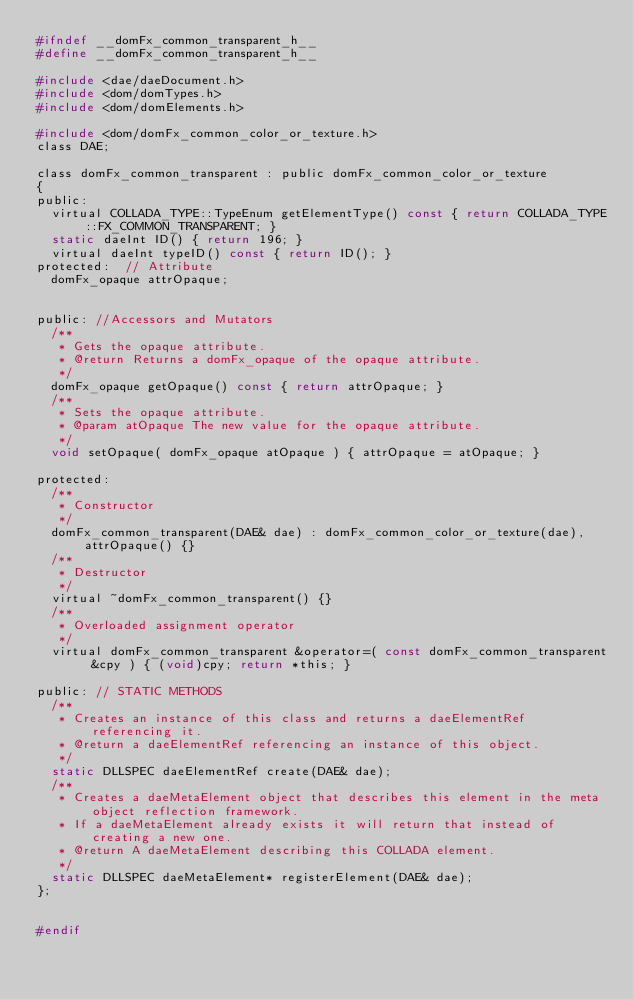Convert code to text. <code><loc_0><loc_0><loc_500><loc_500><_C_>#ifndef __domFx_common_transparent_h__
#define __domFx_common_transparent_h__

#include <dae/daeDocument.h>
#include <dom/domTypes.h>
#include <dom/domElements.h>

#include <dom/domFx_common_color_or_texture.h>
class DAE;

class domFx_common_transparent : public domFx_common_color_or_texture
{
public:
	virtual COLLADA_TYPE::TypeEnum getElementType() const { return COLLADA_TYPE::FX_COMMON_TRANSPARENT; }
	static daeInt ID() { return 196; }
	virtual daeInt typeID() const { return ID(); }
protected:  // Attribute
	domFx_opaque attrOpaque;


public:	//Accessors and Mutators
	/**
	 * Gets the opaque attribute.
	 * @return Returns a domFx_opaque of the opaque attribute.
	 */
	domFx_opaque getOpaque() const { return attrOpaque; }
	/**
	 * Sets the opaque attribute.
	 * @param atOpaque The new value for the opaque attribute.
	 */
	void setOpaque( domFx_opaque atOpaque ) { attrOpaque = atOpaque; }

protected:
	/**
	 * Constructor
	 */
	domFx_common_transparent(DAE& dae) : domFx_common_color_or_texture(dae), attrOpaque() {}
	/**
	 * Destructor
	 */
	virtual ~domFx_common_transparent() {}
	/**
	 * Overloaded assignment operator
	 */
	virtual domFx_common_transparent &operator=( const domFx_common_transparent &cpy ) { (void)cpy; return *this; }

public: // STATIC METHODS
	/**
	 * Creates an instance of this class and returns a daeElementRef referencing it.
	 * @return a daeElementRef referencing an instance of this object.
	 */
	static DLLSPEC daeElementRef create(DAE& dae);
	/**
	 * Creates a daeMetaElement object that describes this element in the meta object reflection framework.
	 * If a daeMetaElement already exists it will return that instead of creating a new one. 
	 * @return A daeMetaElement describing this COLLADA element.
	 */
	static DLLSPEC daeMetaElement* registerElement(DAE& dae);
};


#endif
</code> 